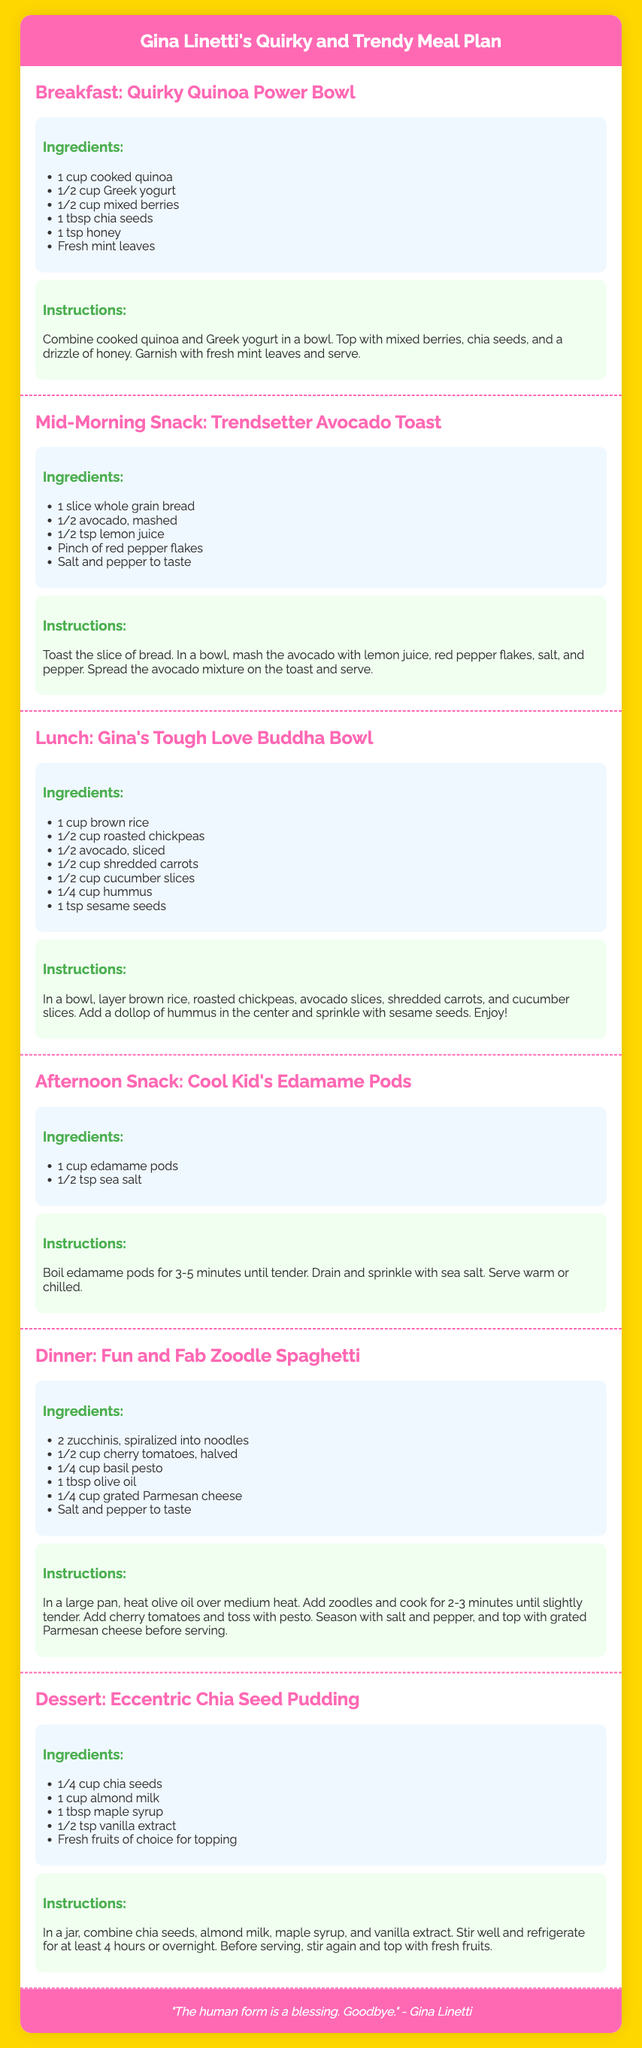What is the title of the meal plan? The title of the meal plan can be found in the header of the document, which is displayed prominently.
Answer: Gina Linetti's Quirky and Trendy Meal Plan How many meals are included in the plan? By counting the meal sections listed in the document, we determine the total number of meals.
Answer: 6 What is the ingredient for the Eccentric Chia Seed Pudding that also starts with the letter "M"? The ingredient is listed in the ingredients section for the pudding dish.
Answer: Maple syrup What type of bowl is featured for lunch? The name of the lunch meal is found at the beginning of that section and describes the type of bowl.
Answer: Buddha Bowl Which ingredient is used in the Fun and Fab Zoodle Spaghetti? This ingredient is listed in the ingredients section for the spaghetti dish.
Answer: Zucchini What is the main ingredient in the breakfast dish? The breakfast dish is introduced with the name and the primary ingredient can be found in its ingredients list.
Answer: Quinoa How long should the chia seed pudding be refrigerated? This information is provided in the instructions section for making the pudding.
Answer: 4 hours Which fruit is recommended for topping the Eccentric Chia Seed Pudding? The pudding's ingredients section allows us to identify this component.
Answer: Fresh fruits of choice 